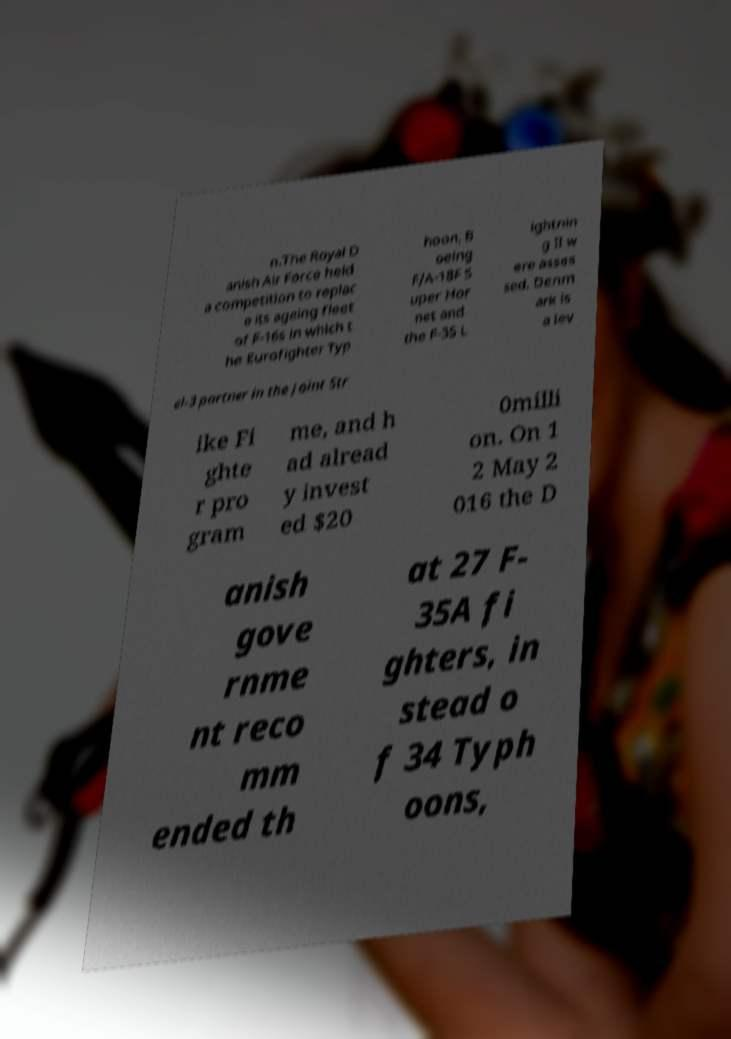Can you read and provide the text displayed in the image?This photo seems to have some interesting text. Can you extract and type it out for me? n.The Royal D anish Air Force held a competition to replac e its ageing fleet of F-16s in which t he Eurofighter Typ hoon, B oeing F/A-18F S uper Hor net and the F-35 L ightnin g II w ere asses sed. Denm ark is a lev el-3 partner in the Joint Str ike Fi ghte r pro gram me, and h ad alread y invest ed $20 0milli on. On 1 2 May 2 016 the D anish gove rnme nt reco mm ended th at 27 F- 35A fi ghters, in stead o f 34 Typh oons, 